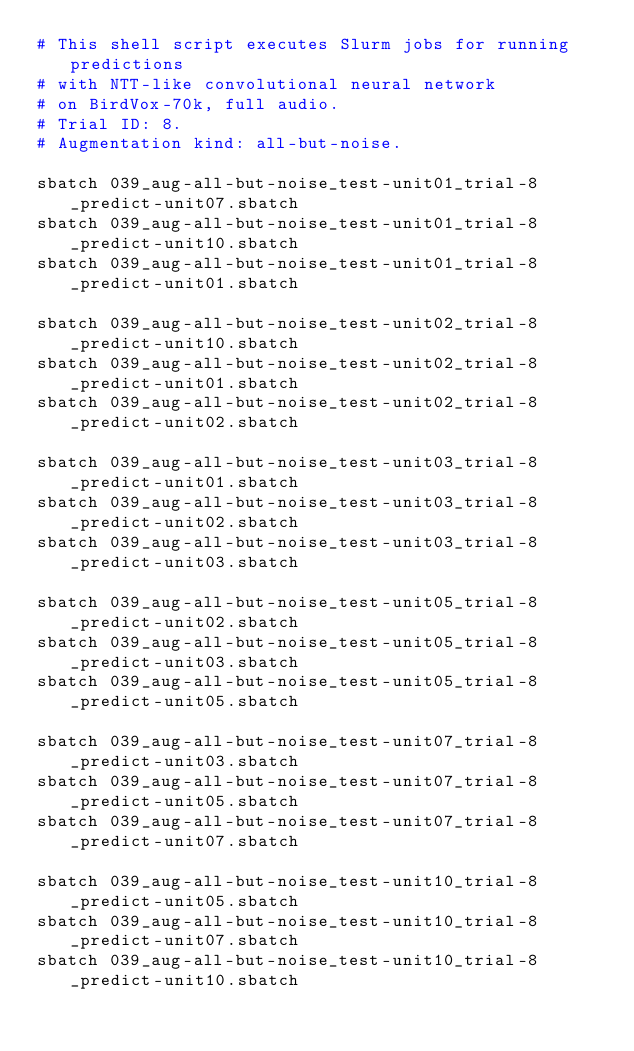<code> <loc_0><loc_0><loc_500><loc_500><_Bash_># This shell script executes Slurm jobs for running predictions
# with NTT-like convolutional neural network
# on BirdVox-70k, full audio.
# Trial ID: 8.
# Augmentation kind: all-but-noise.

sbatch 039_aug-all-but-noise_test-unit01_trial-8_predict-unit07.sbatch
sbatch 039_aug-all-but-noise_test-unit01_trial-8_predict-unit10.sbatch
sbatch 039_aug-all-but-noise_test-unit01_trial-8_predict-unit01.sbatch

sbatch 039_aug-all-but-noise_test-unit02_trial-8_predict-unit10.sbatch
sbatch 039_aug-all-but-noise_test-unit02_trial-8_predict-unit01.sbatch
sbatch 039_aug-all-but-noise_test-unit02_trial-8_predict-unit02.sbatch

sbatch 039_aug-all-but-noise_test-unit03_trial-8_predict-unit01.sbatch
sbatch 039_aug-all-but-noise_test-unit03_trial-8_predict-unit02.sbatch
sbatch 039_aug-all-but-noise_test-unit03_trial-8_predict-unit03.sbatch

sbatch 039_aug-all-but-noise_test-unit05_trial-8_predict-unit02.sbatch
sbatch 039_aug-all-but-noise_test-unit05_trial-8_predict-unit03.sbatch
sbatch 039_aug-all-but-noise_test-unit05_trial-8_predict-unit05.sbatch

sbatch 039_aug-all-but-noise_test-unit07_trial-8_predict-unit03.sbatch
sbatch 039_aug-all-but-noise_test-unit07_trial-8_predict-unit05.sbatch
sbatch 039_aug-all-but-noise_test-unit07_trial-8_predict-unit07.sbatch

sbatch 039_aug-all-but-noise_test-unit10_trial-8_predict-unit05.sbatch
sbatch 039_aug-all-but-noise_test-unit10_trial-8_predict-unit07.sbatch
sbatch 039_aug-all-but-noise_test-unit10_trial-8_predict-unit10.sbatch

</code> 